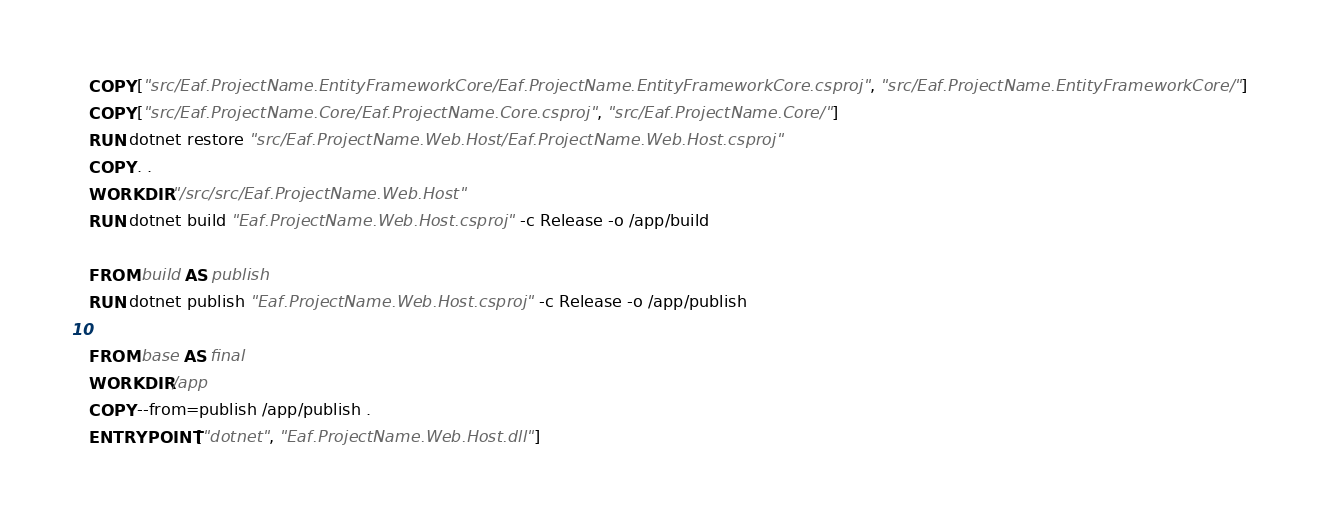Convert code to text. <code><loc_0><loc_0><loc_500><loc_500><_Dockerfile_>COPY ["src/Eaf.ProjectName.EntityFrameworkCore/Eaf.ProjectName.EntityFrameworkCore.csproj", "src/Eaf.ProjectName.EntityFrameworkCore/"]
COPY ["src/Eaf.ProjectName.Core/Eaf.ProjectName.Core.csproj", "src/Eaf.ProjectName.Core/"]
RUN dotnet restore "src/Eaf.ProjectName.Web.Host/Eaf.ProjectName.Web.Host.csproj"
COPY . .
WORKDIR "/src/src/Eaf.ProjectName.Web.Host"
RUN dotnet build "Eaf.ProjectName.Web.Host.csproj" -c Release -o /app/build

FROM build AS publish
RUN dotnet publish "Eaf.ProjectName.Web.Host.csproj" -c Release -o /app/publish

FROM base AS final
WORKDIR /app
COPY --from=publish /app/publish .
ENTRYPOINT ["dotnet", "Eaf.ProjectName.Web.Host.dll"]
</code> 